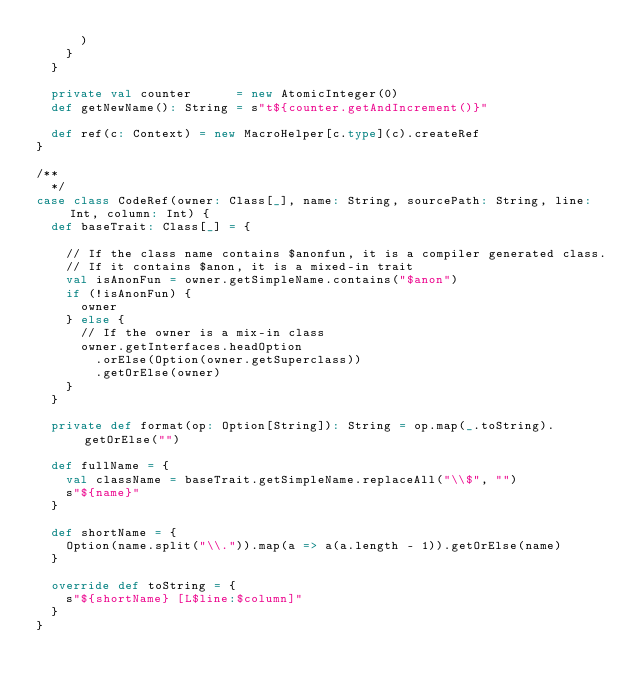Convert code to text. <code><loc_0><loc_0><loc_500><loc_500><_Scala_>      )
    }
  }

  private val counter      = new AtomicInteger(0)
  def getNewName(): String = s"t${counter.getAndIncrement()}"

  def ref(c: Context) = new MacroHelper[c.type](c).createRef
}

/**
  */
case class CodeRef(owner: Class[_], name: String, sourcePath: String, line: Int, column: Int) {
  def baseTrait: Class[_] = {

    // If the class name contains $anonfun, it is a compiler generated class.
    // If it contains $anon, it is a mixed-in trait
    val isAnonFun = owner.getSimpleName.contains("$anon")
    if (!isAnonFun) {
      owner
    } else {
      // If the owner is a mix-in class
      owner.getInterfaces.headOption
        .orElse(Option(owner.getSuperclass))
        .getOrElse(owner)
    }
  }

  private def format(op: Option[String]): String = op.map(_.toString).getOrElse("")

  def fullName = {
    val className = baseTrait.getSimpleName.replaceAll("\\$", "")
    s"${name}"
  }

  def shortName = {
    Option(name.split("\\.")).map(a => a(a.length - 1)).getOrElse(name)
  }

  override def toString = {
    s"${shortName} [L$line:$column]"
  }
}
</code> 